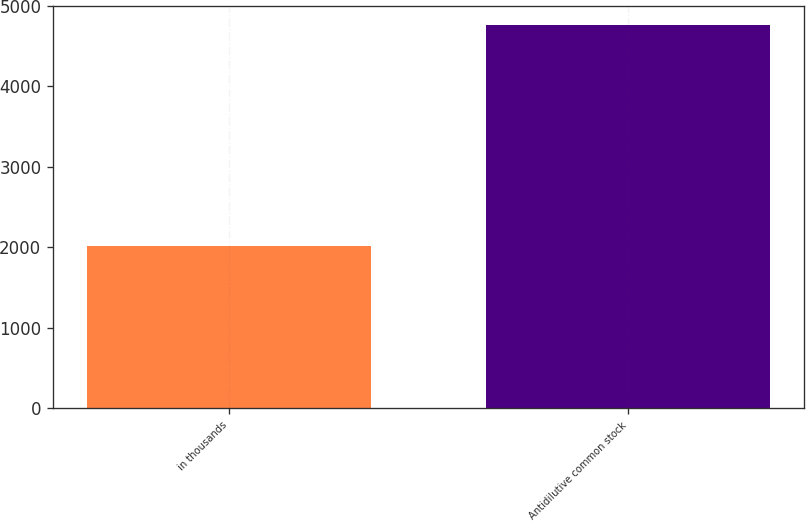<chart> <loc_0><loc_0><loc_500><loc_500><bar_chart><fcel>in thousands<fcel>Antidilutive common stock<nl><fcel>2012<fcel>4762<nl></chart> 